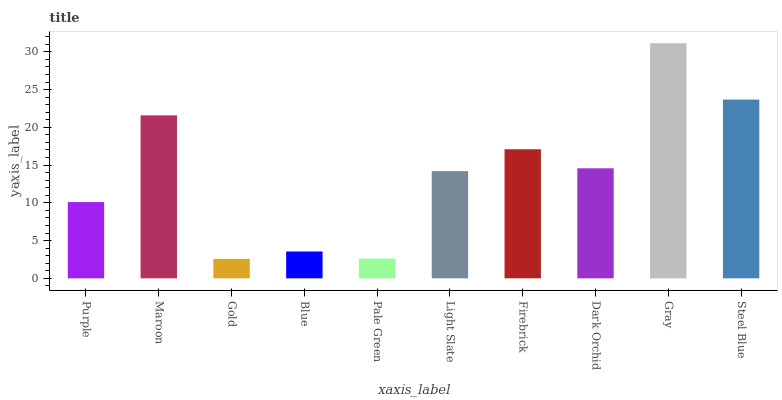Is Maroon the minimum?
Answer yes or no. No. Is Maroon the maximum?
Answer yes or no. No. Is Maroon greater than Purple?
Answer yes or no. Yes. Is Purple less than Maroon?
Answer yes or no. Yes. Is Purple greater than Maroon?
Answer yes or no. No. Is Maroon less than Purple?
Answer yes or no. No. Is Dark Orchid the high median?
Answer yes or no. Yes. Is Light Slate the low median?
Answer yes or no. Yes. Is Pale Green the high median?
Answer yes or no. No. Is Blue the low median?
Answer yes or no. No. 